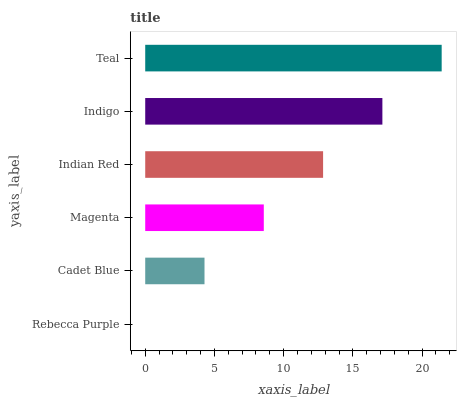Is Rebecca Purple the minimum?
Answer yes or no. Yes. Is Teal the maximum?
Answer yes or no. Yes. Is Cadet Blue the minimum?
Answer yes or no. No. Is Cadet Blue the maximum?
Answer yes or no. No. Is Cadet Blue greater than Rebecca Purple?
Answer yes or no. Yes. Is Rebecca Purple less than Cadet Blue?
Answer yes or no. Yes. Is Rebecca Purple greater than Cadet Blue?
Answer yes or no. No. Is Cadet Blue less than Rebecca Purple?
Answer yes or no. No. Is Indian Red the high median?
Answer yes or no. Yes. Is Magenta the low median?
Answer yes or no. Yes. Is Indigo the high median?
Answer yes or no. No. Is Rebecca Purple the low median?
Answer yes or no. No. 